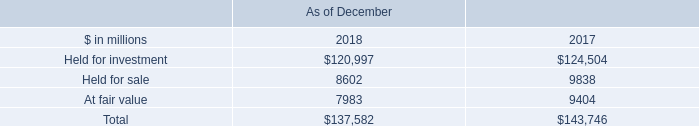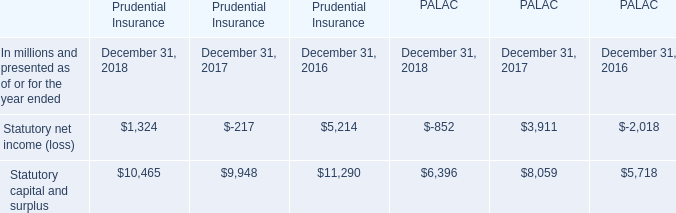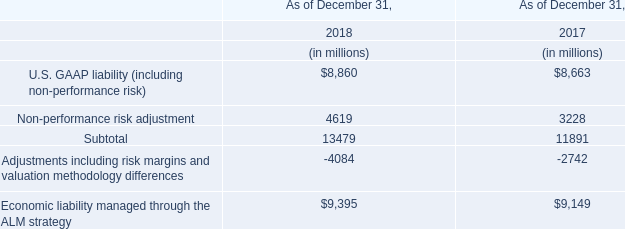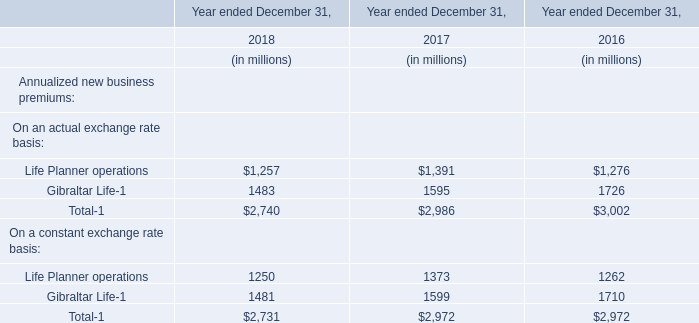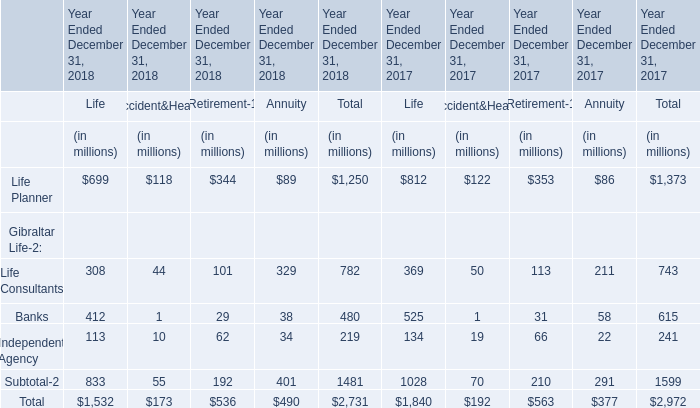In the year with lowest amount of Total-1, what's the increasing rate of Life Planner operations ? 
Computations: ((1373 - 1250) / 1373)
Answer: 0.08958. 